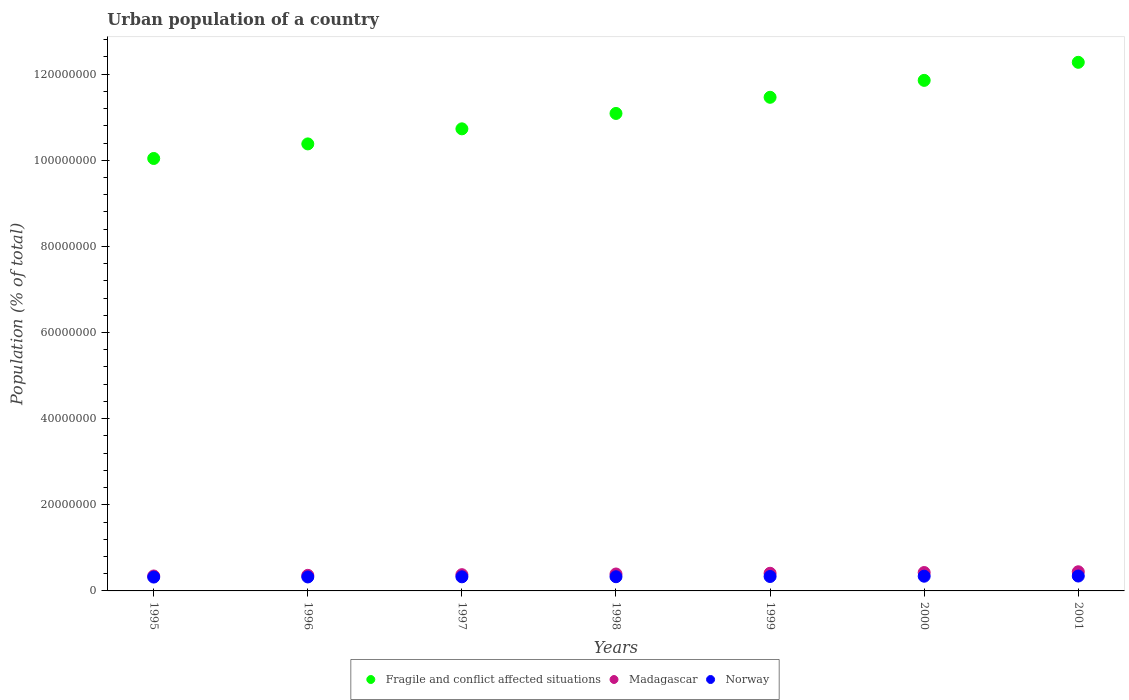How many different coloured dotlines are there?
Give a very brief answer. 3. What is the urban population in Fragile and conflict affected situations in 1999?
Your answer should be very brief. 1.15e+08. Across all years, what is the maximum urban population in Norway?
Make the answer very short. 3.46e+06. Across all years, what is the minimum urban population in Norway?
Offer a terse response. 3.22e+06. In which year was the urban population in Fragile and conflict affected situations minimum?
Provide a short and direct response. 1995. What is the total urban population in Fragile and conflict affected situations in the graph?
Your answer should be very brief. 7.78e+08. What is the difference between the urban population in Norway in 1995 and that in 1998?
Your answer should be very brief. -8.04e+04. What is the difference between the urban population in Fragile and conflict affected situations in 1995 and the urban population in Madagascar in 1999?
Your answer should be very brief. 9.63e+07. What is the average urban population in Norway per year?
Ensure brevity in your answer.  3.32e+06. In the year 2001, what is the difference between the urban population in Madagascar and urban population in Fragile and conflict affected situations?
Offer a terse response. -1.18e+08. In how many years, is the urban population in Fragile and conflict affected situations greater than 100000000 %?
Provide a short and direct response. 7. What is the ratio of the urban population in Madagascar in 1996 to that in 1999?
Your response must be concise. 0.88. Is the difference between the urban population in Madagascar in 2000 and 2001 greater than the difference between the urban population in Fragile and conflict affected situations in 2000 and 2001?
Give a very brief answer. Yes. What is the difference between the highest and the second highest urban population in Madagascar?
Provide a short and direct response. 1.77e+05. What is the difference between the highest and the lowest urban population in Madagascar?
Provide a succinct answer. 9.77e+05. In how many years, is the urban population in Norway greater than the average urban population in Norway taken over all years?
Make the answer very short. 3. Is the sum of the urban population in Norway in 1998 and 1999 greater than the maximum urban population in Fragile and conflict affected situations across all years?
Provide a short and direct response. No. Is it the case that in every year, the sum of the urban population in Norway and urban population in Madagascar  is greater than the urban population in Fragile and conflict affected situations?
Make the answer very short. No. Does the urban population in Fragile and conflict affected situations monotonically increase over the years?
Give a very brief answer. Yes. How many dotlines are there?
Provide a succinct answer. 3. How many years are there in the graph?
Give a very brief answer. 7. Are the values on the major ticks of Y-axis written in scientific E-notation?
Ensure brevity in your answer.  No. Does the graph contain any zero values?
Keep it short and to the point. No. How many legend labels are there?
Make the answer very short. 3. What is the title of the graph?
Keep it short and to the point. Urban population of a country. What is the label or title of the X-axis?
Give a very brief answer. Years. What is the label or title of the Y-axis?
Offer a very short reply. Population (% of total). What is the Population (% of total) in Fragile and conflict affected situations in 1995?
Make the answer very short. 1.00e+08. What is the Population (% of total) in Madagascar in 1995?
Ensure brevity in your answer.  3.47e+06. What is the Population (% of total) in Norway in 1995?
Give a very brief answer. 3.22e+06. What is the Population (% of total) of Fragile and conflict affected situations in 1996?
Provide a succinct answer. 1.04e+08. What is the Population (% of total) of Madagascar in 1996?
Offer a terse response. 3.62e+06. What is the Population (% of total) of Norway in 1996?
Your answer should be very brief. 3.24e+06. What is the Population (% of total) in Fragile and conflict affected situations in 1997?
Your answer should be compact. 1.07e+08. What is the Population (% of total) of Madagascar in 1997?
Your answer should be very brief. 3.77e+06. What is the Population (% of total) in Norway in 1997?
Offer a terse response. 3.27e+06. What is the Population (% of total) of Fragile and conflict affected situations in 1998?
Your response must be concise. 1.11e+08. What is the Population (% of total) of Madagascar in 1998?
Keep it short and to the point. 3.93e+06. What is the Population (% of total) of Norway in 1998?
Your answer should be compact. 3.30e+06. What is the Population (% of total) in Fragile and conflict affected situations in 1999?
Offer a terse response. 1.15e+08. What is the Population (% of total) of Madagascar in 1999?
Offer a terse response. 4.10e+06. What is the Population (% of total) in Norway in 1999?
Give a very brief answer. 3.35e+06. What is the Population (% of total) in Fragile and conflict affected situations in 2000?
Offer a terse response. 1.19e+08. What is the Population (% of total) of Madagascar in 2000?
Offer a terse response. 4.27e+06. What is the Population (% of total) of Norway in 2000?
Offer a terse response. 3.42e+06. What is the Population (% of total) of Fragile and conflict affected situations in 2001?
Give a very brief answer. 1.23e+08. What is the Population (% of total) of Madagascar in 2001?
Make the answer very short. 4.45e+06. What is the Population (% of total) of Norway in 2001?
Give a very brief answer. 3.46e+06. Across all years, what is the maximum Population (% of total) of Fragile and conflict affected situations?
Make the answer very short. 1.23e+08. Across all years, what is the maximum Population (% of total) in Madagascar?
Your response must be concise. 4.45e+06. Across all years, what is the maximum Population (% of total) of Norway?
Your answer should be very brief. 3.46e+06. Across all years, what is the minimum Population (% of total) in Fragile and conflict affected situations?
Give a very brief answer. 1.00e+08. Across all years, what is the minimum Population (% of total) in Madagascar?
Provide a succinct answer. 3.47e+06. Across all years, what is the minimum Population (% of total) of Norway?
Your answer should be compact. 3.22e+06. What is the total Population (% of total) of Fragile and conflict affected situations in the graph?
Your answer should be compact. 7.78e+08. What is the total Population (% of total) of Madagascar in the graph?
Make the answer very short. 2.76e+07. What is the total Population (% of total) of Norway in the graph?
Provide a short and direct response. 2.33e+07. What is the difference between the Population (% of total) in Fragile and conflict affected situations in 1995 and that in 1996?
Give a very brief answer. -3.38e+06. What is the difference between the Population (% of total) of Madagascar in 1995 and that in 1996?
Your answer should be very brief. -1.47e+05. What is the difference between the Population (% of total) in Norway in 1995 and that in 1996?
Make the answer very short. -2.84e+04. What is the difference between the Population (% of total) in Fragile and conflict affected situations in 1995 and that in 1997?
Your answer should be very brief. -6.88e+06. What is the difference between the Population (% of total) of Madagascar in 1995 and that in 1997?
Your response must be concise. -3.01e+05. What is the difference between the Population (% of total) of Norway in 1995 and that in 1997?
Provide a succinct answer. -5.79e+04. What is the difference between the Population (% of total) of Fragile and conflict affected situations in 1995 and that in 1998?
Offer a terse response. -1.05e+07. What is the difference between the Population (% of total) in Madagascar in 1995 and that in 1998?
Ensure brevity in your answer.  -4.62e+05. What is the difference between the Population (% of total) of Norway in 1995 and that in 1998?
Offer a terse response. -8.04e+04. What is the difference between the Population (% of total) of Fragile and conflict affected situations in 1995 and that in 1999?
Offer a very short reply. -1.42e+07. What is the difference between the Population (% of total) in Madagascar in 1995 and that in 1999?
Your response must be concise. -6.28e+05. What is the difference between the Population (% of total) of Norway in 1995 and that in 1999?
Your answer should be very brief. -1.35e+05. What is the difference between the Population (% of total) of Fragile and conflict affected situations in 1995 and that in 2000?
Provide a short and direct response. -1.81e+07. What is the difference between the Population (% of total) of Madagascar in 1995 and that in 2000?
Offer a very short reply. -8.00e+05. What is the difference between the Population (% of total) of Norway in 1995 and that in 2000?
Keep it short and to the point. -2.01e+05. What is the difference between the Population (% of total) in Fragile and conflict affected situations in 1995 and that in 2001?
Provide a short and direct response. -2.23e+07. What is the difference between the Population (% of total) of Madagascar in 1995 and that in 2001?
Your answer should be very brief. -9.77e+05. What is the difference between the Population (% of total) of Norway in 1995 and that in 2001?
Keep it short and to the point. -2.40e+05. What is the difference between the Population (% of total) in Fragile and conflict affected situations in 1996 and that in 1997?
Offer a very short reply. -3.50e+06. What is the difference between the Population (% of total) in Madagascar in 1996 and that in 1997?
Keep it short and to the point. -1.54e+05. What is the difference between the Population (% of total) of Norway in 1996 and that in 1997?
Provide a short and direct response. -2.95e+04. What is the difference between the Population (% of total) of Fragile and conflict affected situations in 1996 and that in 1998?
Make the answer very short. -7.07e+06. What is the difference between the Population (% of total) of Madagascar in 1996 and that in 1998?
Your answer should be compact. -3.15e+05. What is the difference between the Population (% of total) of Norway in 1996 and that in 1998?
Your response must be concise. -5.20e+04. What is the difference between the Population (% of total) of Fragile and conflict affected situations in 1996 and that in 1999?
Offer a very short reply. -1.08e+07. What is the difference between the Population (% of total) of Madagascar in 1996 and that in 1999?
Provide a succinct answer. -4.81e+05. What is the difference between the Population (% of total) of Norway in 1996 and that in 1999?
Your answer should be compact. -1.06e+05. What is the difference between the Population (% of total) in Fragile and conflict affected situations in 1996 and that in 2000?
Make the answer very short. -1.48e+07. What is the difference between the Population (% of total) of Madagascar in 1996 and that in 2000?
Your response must be concise. -6.53e+05. What is the difference between the Population (% of total) in Norway in 1996 and that in 2000?
Your answer should be very brief. -1.73e+05. What is the difference between the Population (% of total) of Fragile and conflict affected situations in 1996 and that in 2001?
Provide a succinct answer. -1.89e+07. What is the difference between the Population (% of total) in Madagascar in 1996 and that in 2001?
Make the answer very short. -8.30e+05. What is the difference between the Population (% of total) in Norway in 1996 and that in 2001?
Your answer should be compact. -2.12e+05. What is the difference between the Population (% of total) in Fragile and conflict affected situations in 1997 and that in 1998?
Keep it short and to the point. -3.58e+06. What is the difference between the Population (% of total) of Madagascar in 1997 and that in 1998?
Offer a terse response. -1.61e+05. What is the difference between the Population (% of total) of Norway in 1997 and that in 1998?
Offer a very short reply. -2.25e+04. What is the difference between the Population (% of total) in Fragile and conflict affected situations in 1997 and that in 1999?
Offer a very short reply. -7.32e+06. What is the difference between the Population (% of total) in Madagascar in 1997 and that in 1999?
Offer a terse response. -3.27e+05. What is the difference between the Population (% of total) in Norway in 1997 and that in 1999?
Make the answer very short. -7.68e+04. What is the difference between the Population (% of total) in Fragile and conflict affected situations in 1997 and that in 2000?
Your answer should be compact. -1.13e+07. What is the difference between the Population (% of total) in Madagascar in 1997 and that in 2000?
Make the answer very short. -4.99e+05. What is the difference between the Population (% of total) in Norway in 1997 and that in 2000?
Provide a succinct answer. -1.43e+05. What is the difference between the Population (% of total) in Fragile and conflict affected situations in 1997 and that in 2001?
Provide a short and direct response. -1.54e+07. What is the difference between the Population (% of total) of Madagascar in 1997 and that in 2001?
Offer a very short reply. -6.76e+05. What is the difference between the Population (% of total) in Norway in 1997 and that in 2001?
Keep it short and to the point. -1.82e+05. What is the difference between the Population (% of total) in Fragile and conflict affected situations in 1998 and that in 1999?
Give a very brief answer. -3.75e+06. What is the difference between the Population (% of total) in Madagascar in 1998 and that in 1999?
Your answer should be very brief. -1.66e+05. What is the difference between the Population (% of total) of Norway in 1998 and that in 1999?
Give a very brief answer. -5.44e+04. What is the difference between the Population (% of total) in Fragile and conflict affected situations in 1998 and that in 2000?
Offer a very short reply. -7.68e+06. What is the difference between the Population (% of total) of Madagascar in 1998 and that in 2000?
Your response must be concise. -3.38e+05. What is the difference between the Population (% of total) in Norway in 1998 and that in 2000?
Your answer should be compact. -1.21e+05. What is the difference between the Population (% of total) in Fragile and conflict affected situations in 1998 and that in 2001?
Keep it short and to the point. -1.19e+07. What is the difference between the Population (% of total) in Madagascar in 1998 and that in 2001?
Your answer should be very brief. -5.15e+05. What is the difference between the Population (% of total) of Norway in 1998 and that in 2001?
Your answer should be very brief. -1.60e+05. What is the difference between the Population (% of total) in Fragile and conflict affected situations in 1999 and that in 2000?
Give a very brief answer. -3.93e+06. What is the difference between the Population (% of total) of Madagascar in 1999 and that in 2000?
Provide a succinct answer. -1.72e+05. What is the difference between the Population (% of total) of Norway in 1999 and that in 2000?
Your response must be concise. -6.65e+04. What is the difference between the Population (% of total) of Fragile and conflict affected situations in 1999 and that in 2001?
Offer a terse response. -8.12e+06. What is the difference between the Population (% of total) in Madagascar in 1999 and that in 2001?
Your response must be concise. -3.49e+05. What is the difference between the Population (% of total) of Norway in 1999 and that in 2001?
Make the answer very short. -1.06e+05. What is the difference between the Population (% of total) of Fragile and conflict affected situations in 2000 and that in 2001?
Make the answer very short. -4.19e+06. What is the difference between the Population (% of total) of Madagascar in 2000 and that in 2001?
Ensure brevity in your answer.  -1.77e+05. What is the difference between the Population (% of total) in Norway in 2000 and that in 2001?
Your answer should be very brief. -3.90e+04. What is the difference between the Population (% of total) in Fragile and conflict affected situations in 1995 and the Population (% of total) in Madagascar in 1996?
Ensure brevity in your answer.  9.68e+07. What is the difference between the Population (% of total) in Fragile and conflict affected situations in 1995 and the Population (% of total) in Norway in 1996?
Offer a very short reply. 9.72e+07. What is the difference between the Population (% of total) in Madagascar in 1995 and the Population (% of total) in Norway in 1996?
Offer a very short reply. 2.26e+05. What is the difference between the Population (% of total) in Fragile and conflict affected situations in 1995 and the Population (% of total) in Madagascar in 1997?
Your answer should be compact. 9.66e+07. What is the difference between the Population (% of total) in Fragile and conflict affected situations in 1995 and the Population (% of total) in Norway in 1997?
Provide a succinct answer. 9.71e+07. What is the difference between the Population (% of total) of Madagascar in 1995 and the Population (% of total) of Norway in 1997?
Offer a terse response. 1.97e+05. What is the difference between the Population (% of total) in Fragile and conflict affected situations in 1995 and the Population (% of total) in Madagascar in 1998?
Offer a very short reply. 9.65e+07. What is the difference between the Population (% of total) of Fragile and conflict affected situations in 1995 and the Population (% of total) of Norway in 1998?
Give a very brief answer. 9.71e+07. What is the difference between the Population (% of total) in Madagascar in 1995 and the Population (% of total) in Norway in 1998?
Keep it short and to the point. 1.74e+05. What is the difference between the Population (% of total) in Fragile and conflict affected situations in 1995 and the Population (% of total) in Madagascar in 1999?
Provide a short and direct response. 9.63e+07. What is the difference between the Population (% of total) in Fragile and conflict affected situations in 1995 and the Population (% of total) in Norway in 1999?
Your answer should be compact. 9.71e+07. What is the difference between the Population (% of total) in Madagascar in 1995 and the Population (% of total) in Norway in 1999?
Ensure brevity in your answer.  1.20e+05. What is the difference between the Population (% of total) in Fragile and conflict affected situations in 1995 and the Population (% of total) in Madagascar in 2000?
Offer a terse response. 9.61e+07. What is the difference between the Population (% of total) in Fragile and conflict affected situations in 1995 and the Population (% of total) in Norway in 2000?
Offer a terse response. 9.70e+07. What is the difference between the Population (% of total) in Madagascar in 1995 and the Population (% of total) in Norway in 2000?
Give a very brief answer. 5.34e+04. What is the difference between the Population (% of total) of Fragile and conflict affected situations in 1995 and the Population (% of total) of Madagascar in 2001?
Your answer should be compact. 9.60e+07. What is the difference between the Population (% of total) in Fragile and conflict affected situations in 1995 and the Population (% of total) in Norway in 2001?
Provide a short and direct response. 9.70e+07. What is the difference between the Population (% of total) of Madagascar in 1995 and the Population (% of total) of Norway in 2001?
Your response must be concise. 1.44e+04. What is the difference between the Population (% of total) of Fragile and conflict affected situations in 1996 and the Population (% of total) of Madagascar in 1997?
Keep it short and to the point. 1.00e+08. What is the difference between the Population (% of total) of Fragile and conflict affected situations in 1996 and the Population (% of total) of Norway in 1997?
Make the answer very short. 1.01e+08. What is the difference between the Population (% of total) of Madagascar in 1996 and the Population (% of total) of Norway in 1997?
Your response must be concise. 3.44e+05. What is the difference between the Population (% of total) in Fragile and conflict affected situations in 1996 and the Population (% of total) in Madagascar in 1998?
Offer a very short reply. 9.99e+07. What is the difference between the Population (% of total) of Fragile and conflict affected situations in 1996 and the Population (% of total) of Norway in 1998?
Make the answer very short. 1.01e+08. What is the difference between the Population (% of total) of Madagascar in 1996 and the Population (% of total) of Norway in 1998?
Ensure brevity in your answer.  3.22e+05. What is the difference between the Population (% of total) in Fragile and conflict affected situations in 1996 and the Population (% of total) in Madagascar in 1999?
Offer a terse response. 9.97e+07. What is the difference between the Population (% of total) of Fragile and conflict affected situations in 1996 and the Population (% of total) of Norway in 1999?
Keep it short and to the point. 1.00e+08. What is the difference between the Population (% of total) in Madagascar in 1996 and the Population (% of total) in Norway in 1999?
Provide a succinct answer. 2.67e+05. What is the difference between the Population (% of total) in Fragile and conflict affected situations in 1996 and the Population (% of total) in Madagascar in 2000?
Make the answer very short. 9.95e+07. What is the difference between the Population (% of total) of Fragile and conflict affected situations in 1996 and the Population (% of total) of Norway in 2000?
Ensure brevity in your answer.  1.00e+08. What is the difference between the Population (% of total) of Madagascar in 1996 and the Population (% of total) of Norway in 2000?
Make the answer very short. 2.01e+05. What is the difference between the Population (% of total) of Fragile and conflict affected situations in 1996 and the Population (% of total) of Madagascar in 2001?
Give a very brief answer. 9.93e+07. What is the difference between the Population (% of total) of Fragile and conflict affected situations in 1996 and the Population (% of total) of Norway in 2001?
Make the answer very short. 1.00e+08. What is the difference between the Population (% of total) in Madagascar in 1996 and the Population (% of total) in Norway in 2001?
Ensure brevity in your answer.  1.62e+05. What is the difference between the Population (% of total) of Fragile and conflict affected situations in 1997 and the Population (% of total) of Madagascar in 1998?
Offer a very short reply. 1.03e+08. What is the difference between the Population (% of total) in Fragile and conflict affected situations in 1997 and the Population (% of total) in Norway in 1998?
Offer a terse response. 1.04e+08. What is the difference between the Population (% of total) of Madagascar in 1997 and the Population (% of total) of Norway in 1998?
Keep it short and to the point. 4.76e+05. What is the difference between the Population (% of total) in Fragile and conflict affected situations in 1997 and the Population (% of total) in Madagascar in 1999?
Make the answer very short. 1.03e+08. What is the difference between the Population (% of total) of Fragile and conflict affected situations in 1997 and the Population (% of total) of Norway in 1999?
Offer a terse response. 1.04e+08. What is the difference between the Population (% of total) of Madagascar in 1997 and the Population (% of total) of Norway in 1999?
Your response must be concise. 4.21e+05. What is the difference between the Population (% of total) of Fragile and conflict affected situations in 1997 and the Population (% of total) of Madagascar in 2000?
Ensure brevity in your answer.  1.03e+08. What is the difference between the Population (% of total) in Fragile and conflict affected situations in 1997 and the Population (% of total) in Norway in 2000?
Make the answer very short. 1.04e+08. What is the difference between the Population (% of total) in Madagascar in 1997 and the Population (% of total) in Norway in 2000?
Offer a terse response. 3.55e+05. What is the difference between the Population (% of total) in Fragile and conflict affected situations in 1997 and the Population (% of total) in Madagascar in 2001?
Your answer should be compact. 1.03e+08. What is the difference between the Population (% of total) of Fragile and conflict affected situations in 1997 and the Population (% of total) of Norway in 2001?
Provide a short and direct response. 1.04e+08. What is the difference between the Population (% of total) of Madagascar in 1997 and the Population (% of total) of Norway in 2001?
Your answer should be very brief. 3.16e+05. What is the difference between the Population (% of total) in Fragile and conflict affected situations in 1998 and the Population (% of total) in Madagascar in 1999?
Provide a short and direct response. 1.07e+08. What is the difference between the Population (% of total) in Fragile and conflict affected situations in 1998 and the Population (% of total) in Norway in 1999?
Ensure brevity in your answer.  1.08e+08. What is the difference between the Population (% of total) in Madagascar in 1998 and the Population (% of total) in Norway in 1999?
Provide a short and direct response. 5.82e+05. What is the difference between the Population (% of total) in Fragile and conflict affected situations in 1998 and the Population (% of total) in Madagascar in 2000?
Give a very brief answer. 1.07e+08. What is the difference between the Population (% of total) of Fragile and conflict affected situations in 1998 and the Population (% of total) of Norway in 2000?
Your answer should be compact. 1.07e+08. What is the difference between the Population (% of total) in Madagascar in 1998 and the Population (% of total) in Norway in 2000?
Give a very brief answer. 5.15e+05. What is the difference between the Population (% of total) in Fragile and conflict affected situations in 1998 and the Population (% of total) in Madagascar in 2001?
Provide a short and direct response. 1.06e+08. What is the difference between the Population (% of total) in Fragile and conflict affected situations in 1998 and the Population (% of total) in Norway in 2001?
Offer a very short reply. 1.07e+08. What is the difference between the Population (% of total) of Madagascar in 1998 and the Population (% of total) of Norway in 2001?
Offer a terse response. 4.76e+05. What is the difference between the Population (% of total) in Fragile and conflict affected situations in 1999 and the Population (% of total) in Madagascar in 2000?
Offer a terse response. 1.10e+08. What is the difference between the Population (% of total) of Fragile and conflict affected situations in 1999 and the Population (% of total) of Norway in 2000?
Your answer should be very brief. 1.11e+08. What is the difference between the Population (% of total) in Madagascar in 1999 and the Population (% of total) in Norway in 2000?
Your answer should be compact. 6.82e+05. What is the difference between the Population (% of total) of Fragile and conflict affected situations in 1999 and the Population (% of total) of Madagascar in 2001?
Provide a succinct answer. 1.10e+08. What is the difference between the Population (% of total) in Fragile and conflict affected situations in 1999 and the Population (% of total) in Norway in 2001?
Offer a very short reply. 1.11e+08. What is the difference between the Population (% of total) in Madagascar in 1999 and the Population (% of total) in Norway in 2001?
Offer a very short reply. 6.43e+05. What is the difference between the Population (% of total) of Fragile and conflict affected situations in 2000 and the Population (% of total) of Madagascar in 2001?
Give a very brief answer. 1.14e+08. What is the difference between the Population (% of total) of Fragile and conflict affected situations in 2000 and the Population (% of total) of Norway in 2001?
Your answer should be compact. 1.15e+08. What is the difference between the Population (% of total) of Madagascar in 2000 and the Population (% of total) of Norway in 2001?
Offer a very short reply. 8.14e+05. What is the average Population (% of total) in Fragile and conflict affected situations per year?
Your response must be concise. 1.11e+08. What is the average Population (% of total) of Madagascar per year?
Provide a short and direct response. 3.94e+06. What is the average Population (% of total) in Norway per year?
Offer a very short reply. 3.32e+06. In the year 1995, what is the difference between the Population (% of total) in Fragile and conflict affected situations and Population (% of total) in Madagascar?
Provide a succinct answer. 9.69e+07. In the year 1995, what is the difference between the Population (% of total) of Fragile and conflict affected situations and Population (% of total) of Norway?
Keep it short and to the point. 9.72e+07. In the year 1995, what is the difference between the Population (% of total) of Madagascar and Population (% of total) of Norway?
Provide a short and direct response. 2.55e+05. In the year 1996, what is the difference between the Population (% of total) of Fragile and conflict affected situations and Population (% of total) of Madagascar?
Ensure brevity in your answer.  1.00e+08. In the year 1996, what is the difference between the Population (% of total) of Fragile and conflict affected situations and Population (% of total) of Norway?
Provide a succinct answer. 1.01e+08. In the year 1996, what is the difference between the Population (% of total) of Madagascar and Population (% of total) of Norway?
Provide a short and direct response. 3.74e+05. In the year 1997, what is the difference between the Population (% of total) in Fragile and conflict affected situations and Population (% of total) in Madagascar?
Ensure brevity in your answer.  1.04e+08. In the year 1997, what is the difference between the Population (% of total) of Fragile and conflict affected situations and Population (% of total) of Norway?
Ensure brevity in your answer.  1.04e+08. In the year 1997, what is the difference between the Population (% of total) in Madagascar and Population (% of total) in Norway?
Provide a succinct answer. 4.98e+05. In the year 1998, what is the difference between the Population (% of total) in Fragile and conflict affected situations and Population (% of total) in Madagascar?
Offer a very short reply. 1.07e+08. In the year 1998, what is the difference between the Population (% of total) of Fragile and conflict affected situations and Population (% of total) of Norway?
Give a very brief answer. 1.08e+08. In the year 1998, what is the difference between the Population (% of total) of Madagascar and Population (% of total) of Norway?
Your answer should be compact. 6.36e+05. In the year 1999, what is the difference between the Population (% of total) of Fragile and conflict affected situations and Population (% of total) of Madagascar?
Provide a short and direct response. 1.11e+08. In the year 1999, what is the difference between the Population (% of total) of Fragile and conflict affected situations and Population (% of total) of Norway?
Your answer should be compact. 1.11e+08. In the year 1999, what is the difference between the Population (% of total) in Madagascar and Population (% of total) in Norway?
Ensure brevity in your answer.  7.48e+05. In the year 2000, what is the difference between the Population (% of total) in Fragile and conflict affected situations and Population (% of total) in Madagascar?
Offer a terse response. 1.14e+08. In the year 2000, what is the difference between the Population (% of total) in Fragile and conflict affected situations and Population (% of total) in Norway?
Offer a terse response. 1.15e+08. In the year 2000, what is the difference between the Population (% of total) in Madagascar and Population (% of total) in Norway?
Keep it short and to the point. 8.53e+05. In the year 2001, what is the difference between the Population (% of total) in Fragile and conflict affected situations and Population (% of total) in Madagascar?
Ensure brevity in your answer.  1.18e+08. In the year 2001, what is the difference between the Population (% of total) of Fragile and conflict affected situations and Population (% of total) of Norway?
Your answer should be very brief. 1.19e+08. In the year 2001, what is the difference between the Population (% of total) in Madagascar and Population (% of total) in Norway?
Your answer should be very brief. 9.91e+05. What is the ratio of the Population (% of total) of Fragile and conflict affected situations in 1995 to that in 1996?
Offer a terse response. 0.97. What is the ratio of the Population (% of total) of Madagascar in 1995 to that in 1996?
Keep it short and to the point. 0.96. What is the ratio of the Population (% of total) in Norway in 1995 to that in 1996?
Your answer should be very brief. 0.99. What is the ratio of the Population (% of total) of Fragile and conflict affected situations in 1995 to that in 1997?
Ensure brevity in your answer.  0.94. What is the ratio of the Population (% of total) in Madagascar in 1995 to that in 1997?
Provide a short and direct response. 0.92. What is the ratio of the Population (% of total) in Norway in 1995 to that in 1997?
Offer a terse response. 0.98. What is the ratio of the Population (% of total) in Fragile and conflict affected situations in 1995 to that in 1998?
Ensure brevity in your answer.  0.91. What is the ratio of the Population (% of total) in Madagascar in 1995 to that in 1998?
Provide a short and direct response. 0.88. What is the ratio of the Population (% of total) in Norway in 1995 to that in 1998?
Provide a short and direct response. 0.98. What is the ratio of the Population (% of total) of Fragile and conflict affected situations in 1995 to that in 1999?
Offer a terse response. 0.88. What is the ratio of the Population (% of total) of Madagascar in 1995 to that in 1999?
Your response must be concise. 0.85. What is the ratio of the Population (% of total) in Norway in 1995 to that in 1999?
Ensure brevity in your answer.  0.96. What is the ratio of the Population (% of total) in Fragile and conflict affected situations in 1995 to that in 2000?
Your answer should be very brief. 0.85. What is the ratio of the Population (% of total) in Madagascar in 1995 to that in 2000?
Keep it short and to the point. 0.81. What is the ratio of the Population (% of total) in Norway in 1995 to that in 2000?
Your response must be concise. 0.94. What is the ratio of the Population (% of total) in Fragile and conflict affected situations in 1995 to that in 2001?
Your answer should be very brief. 0.82. What is the ratio of the Population (% of total) in Madagascar in 1995 to that in 2001?
Provide a short and direct response. 0.78. What is the ratio of the Population (% of total) in Norway in 1995 to that in 2001?
Offer a very short reply. 0.93. What is the ratio of the Population (% of total) of Fragile and conflict affected situations in 1996 to that in 1997?
Give a very brief answer. 0.97. What is the ratio of the Population (% of total) in Madagascar in 1996 to that in 1997?
Your answer should be compact. 0.96. What is the ratio of the Population (% of total) of Fragile and conflict affected situations in 1996 to that in 1998?
Keep it short and to the point. 0.94. What is the ratio of the Population (% of total) in Madagascar in 1996 to that in 1998?
Ensure brevity in your answer.  0.92. What is the ratio of the Population (% of total) of Norway in 1996 to that in 1998?
Your answer should be very brief. 0.98. What is the ratio of the Population (% of total) of Fragile and conflict affected situations in 1996 to that in 1999?
Provide a succinct answer. 0.91. What is the ratio of the Population (% of total) in Madagascar in 1996 to that in 1999?
Provide a succinct answer. 0.88. What is the ratio of the Population (% of total) of Norway in 1996 to that in 1999?
Offer a very short reply. 0.97. What is the ratio of the Population (% of total) in Fragile and conflict affected situations in 1996 to that in 2000?
Keep it short and to the point. 0.88. What is the ratio of the Population (% of total) of Madagascar in 1996 to that in 2000?
Make the answer very short. 0.85. What is the ratio of the Population (% of total) in Norway in 1996 to that in 2000?
Provide a succinct answer. 0.95. What is the ratio of the Population (% of total) of Fragile and conflict affected situations in 1996 to that in 2001?
Keep it short and to the point. 0.85. What is the ratio of the Population (% of total) of Madagascar in 1996 to that in 2001?
Offer a very short reply. 0.81. What is the ratio of the Population (% of total) in Norway in 1996 to that in 2001?
Offer a terse response. 0.94. What is the ratio of the Population (% of total) in Fragile and conflict affected situations in 1997 to that in 1998?
Your response must be concise. 0.97. What is the ratio of the Population (% of total) of Madagascar in 1997 to that in 1998?
Offer a very short reply. 0.96. What is the ratio of the Population (% of total) of Fragile and conflict affected situations in 1997 to that in 1999?
Your response must be concise. 0.94. What is the ratio of the Population (% of total) of Madagascar in 1997 to that in 1999?
Ensure brevity in your answer.  0.92. What is the ratio of the Population (% of total) in Norway in 1997 to that in 1999?
Offer a terse response. 0.98. What is the ratio of the Population (% of total) of Fragile and conflict affected situations in 1997 to that in 2000?
Keep it short and to the point. 0.91. What is the ratio of the Population (% of total) of Madagascar in 1997 to that in 2000?
Your answer should be compact. 0.88. What is the ratio of the Population (% of total) of Norway in 1997 to that in 2000?
Ensure brevity in your answer.  0.96. What is the ratio of the Population (% of total) in Fragile and conflict affected situations in 1997 to that in 2001?
Offer a terse response. 0.87. What is the ratio of the Population (% of total) in Madagascar in 1997 to that in 2001?
Provide a succinct answer. 0.85. What is the ratio of the Population (% of total) of Norway in 1997 to that in 2001?
Provide a succinct answer. 0.95. What is the ratio of the Population (% of total) in Fragile and conflict affected situations in 1998 to that in 1999?
Your answer should be very brief. 0.97. What is the ratio of the Population (% of total) in Madagascar in 1998 to that in 1999?
Keep it short and to the point. 0.96. What is the ratio of the Population (% of total) in Norway in 1998 to that in 1999?
Give a very brief answer. 0.98. What is the ratio of the Population (% of total) of Fragile and conflict affected situations in 1998 to that in 2000?
Offer a terse response. 0.94. What is the ratio of the Population (% of total) in Madagascar in 1998 to that in 2000?
Your answer should be compact. 0.92. What is the ratio of the Population (% of total) in Norway in 1998 to that in 2000?
Offer a very short reply. 0.96. What is the ratio of the Population (% of total) of Fragile and conflict affected situations in 1998 to that in 2001?
Your answer should be compact. 0.9. What is the ratio of the Population (% of total) in Madagascar in 1998 to that in 2001?
Keep it short and to the point. 0.88. What is the ratio of the Population (% of total) in Norway in 1998 to that in 2001?
Offer a terse response. 0.95. What is the ratio of the Population (% of total) of Fragile and conflict affected situations in 1999 to that in 2000?
Make the answer very short. 0.97. What is the ratio of the Population (% of total) in Madagascar in 1999 to that in 2000?
Make the answer very short. 0.96. What is the ratio of the Population (% of total) of Norway in 1999 to that in 2000?
Offer a very short reply. 0.98. What is the ratio of the Population (% of total) of Fragile and conflict affected situations in 1999 to that in 2001?
Your answer should be compact. 0.93. What is the ratio of the Population (% of total) in Madagascar in 1999 to that in 2001?
Your response must be concise. 0.92. What is the ratio of the Population (% of total) of Norway in 1999 to that in 2001?
Make the answer very short. 0.97. What is the ratio of the Population (% of total) in Fragile and conflict affected situations in 2000 to that in 2001?
Your answer should be compact. 0.97. What is the ratio of the Population (% of total) of Madagascar in 2000 to that in 2001?
Ensure brevity in your answer.  0.96. What is the ratio of the Population (% of total) of Norway in 2000 to that in 2001?
Your answer should be very brief. 0.99. What is the difference between the highest and the second highest Population (% of total) in Fragile and conflict affected situations?
Your response must be concise. 4.19e+06. What is the difference between the highest and the second highest Population (% of total) in Madagascar?
Ensure brevity in your answer.  1.77e+05. What is the difference between the highest and the second highest Population (% of total) in Norway?
Your answer should be compact. 3.90e+04. What is the difference between the highest and the lowest Population (% of total) of Fragile and conflict affected situations?
Ensure brevity in your answer.  2.23e+07. What is the difference between the highest and the lowest Population (% of total) in Madagascar?
Keep it short and to the point. 9.77e+05. What is the difference between the highest and the lowest Population (% of total) in Norway?
Your answer should be very brief. 2.40e+05. 